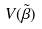Convert formula to latex. <formula><loc_0><loc_0><loc_500><loc_500>V ( \tilde { \beta } )</formula> 